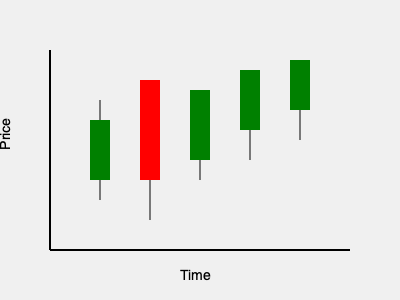Based on the candlestick chart of the CAC 40 index shown above, what is the overall trend in the French stock market, and what would Jacques de Larosière likely advise about this market condition? To analyze this candlestick chart and determine the market trend, we need to follow these steps:

1. Identify the components of each candlestick:
   - The thin line (wick) represents the high and low prices for the period.
   - The thick body represents the opening and closing prices.
   - Green bodies indicate the closing price was higher than the opening (bullish).
   - Red bodies indicate the closing price was lower than the opening (bearish).

2. Analyze the pattern:
   - We see 5 candlesticks, with 4 green and 1 red.
   - The overall direction is upward, with each subsequent candlestick generally higher than the previous one.

3. Interpret the trend:
   - The predominance of green candlesticks suggests more buying pressure than selling.
   - The upward movement of prices indicates a bullish trend.

4. Consider Jacques de Larosière's perspective:
   - As a former governor of the Banque de France and managing director of the IMF, de Larosière would likely emphasize caution and thorough analysis.
   - However, given his expertise in financial stability, he would probably recognize the positive momentum in the market.

5. Formulate advice based on the trend and de Larosière's approach:
   - The bullish trend suggests potential opportunities for growth.
   - De Larosière would likely advise to capitalize on the upward momentum while maintaining vigilance for any signs of market instability or overheating.

Given these factors, Jacques de Larosière would probably advise cautious optimism and strategic investment in the French stock market, while closely monitoring economic indicators to ensure the trend's sustainability.
Answer: Bullish trend; cautious optimism and strategic investment with close monitoring 